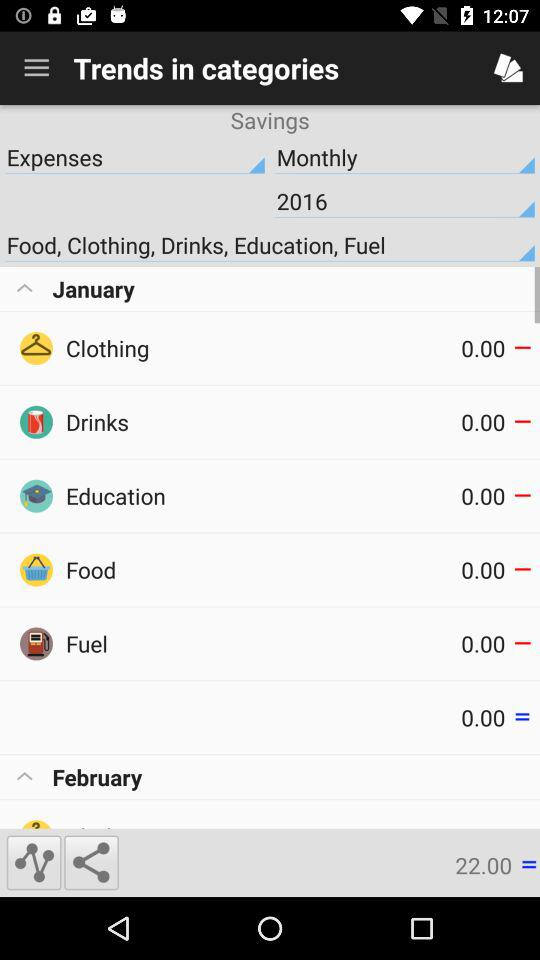What are the different categories under January? The different categories are: "Clothing", "Drinks", "Education", "Food", and "Fuel". 